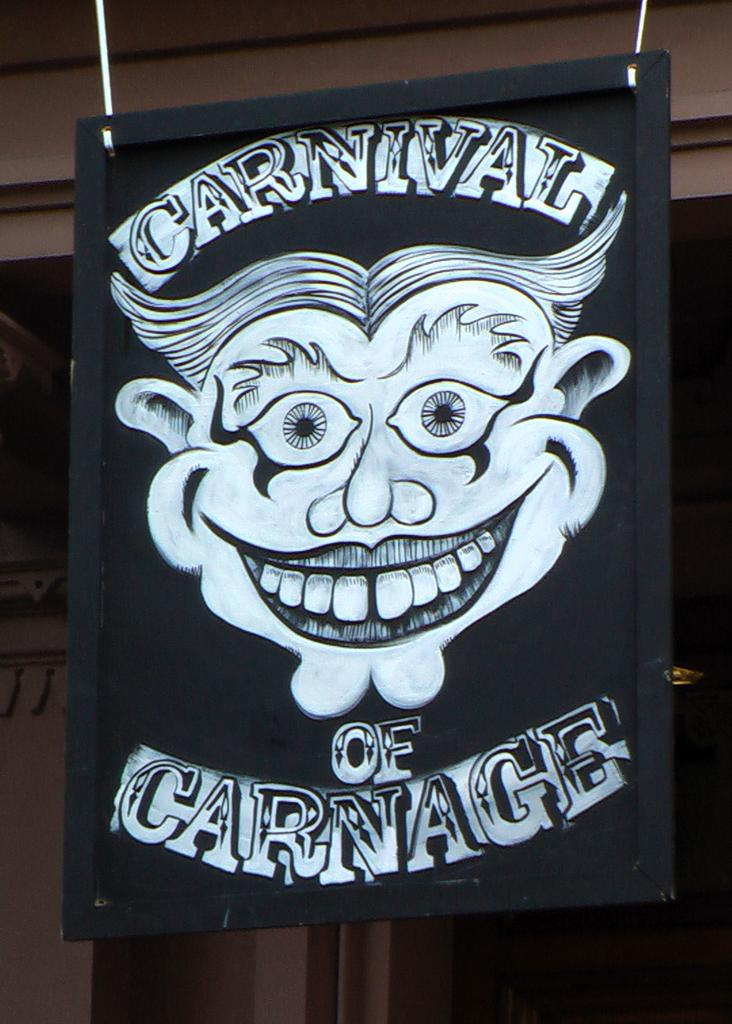What type of board is present in the image? There is a blackboard in the image. How is the blackboard positioned in the image? The blackboard is hanged from the roof. What is depicted on the blackboard? There is a joker face on the board. Is there any text on the blackboard? Yes, there is text on the board. Can you see a drum being played on the blackboard in the image? No, there is no drum or any indication of a drum being played on the blackboard in the image. 